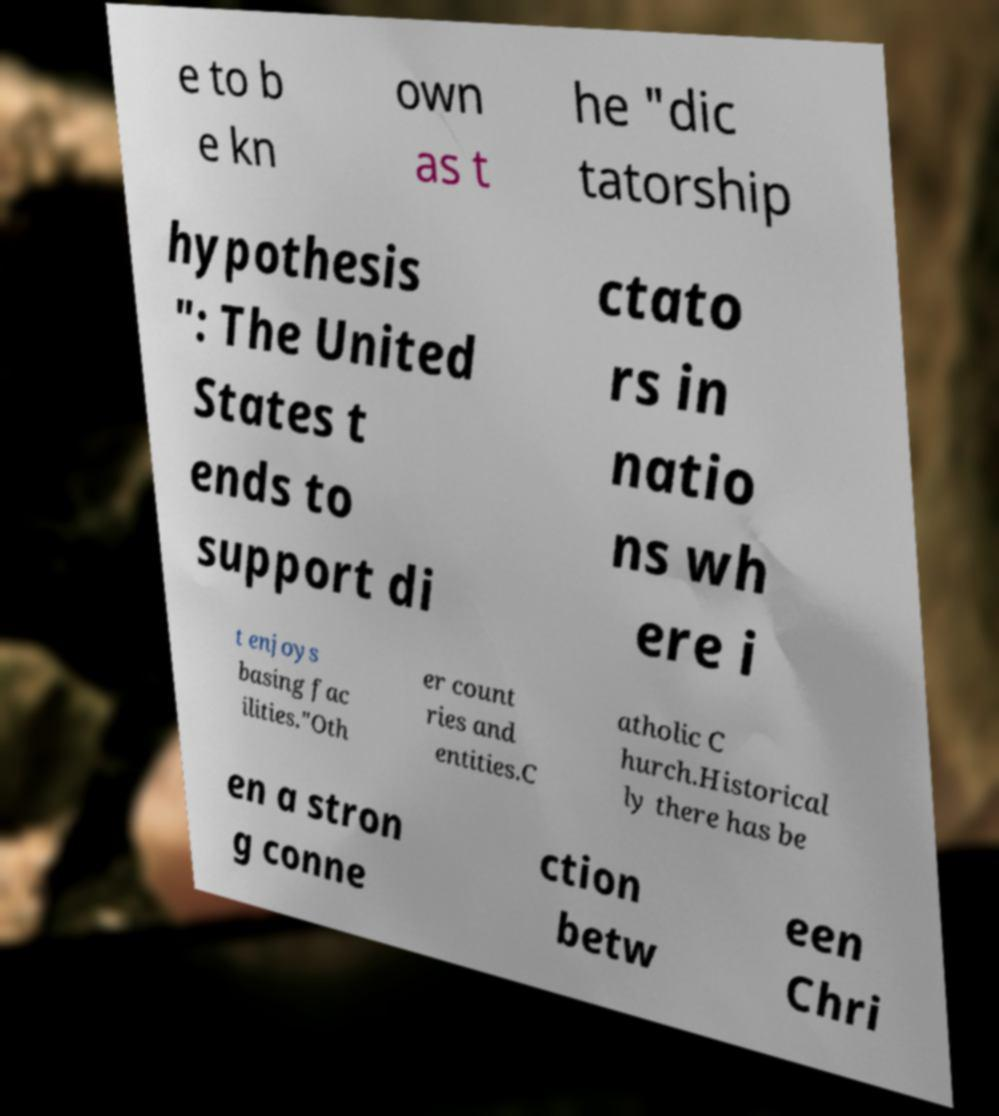Please identify and transcribe the text found in this image. e to b e kn own as t he "dic tatorship hypothesis ": The United States t ends to support di ctato rs in natio ns wh ere i t enjoys basing fac ilities."Oth er count ries and entities.C atholic C hurch.Historical ly there has be en a stron g conne ction betw een Chri 